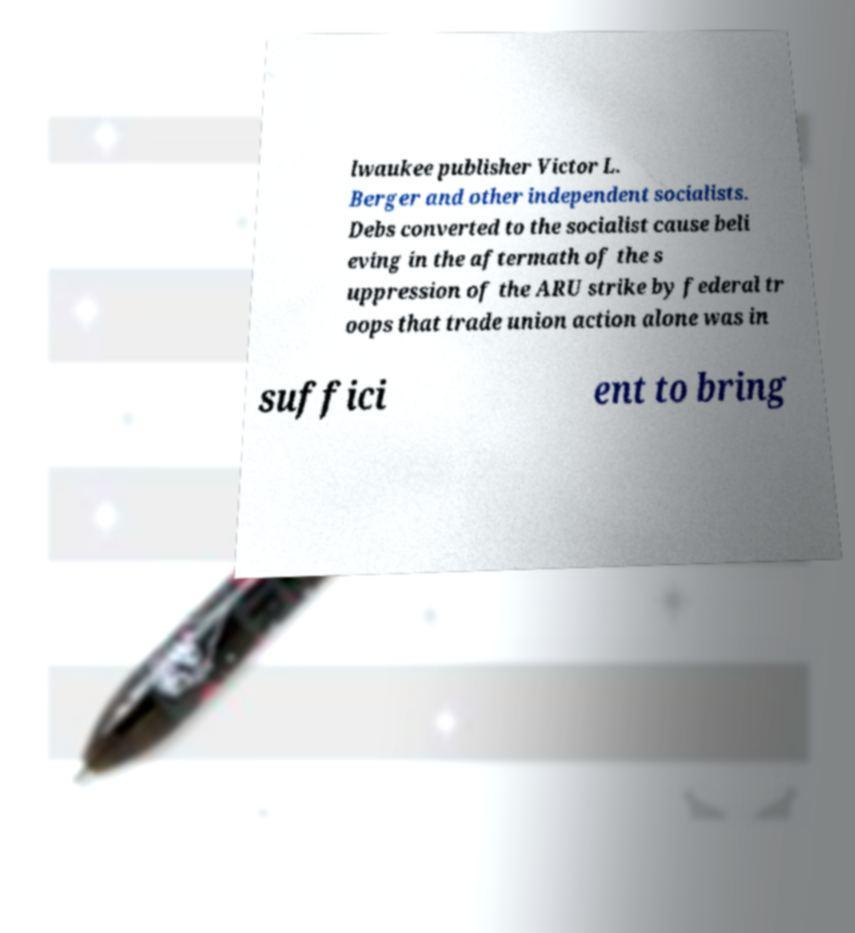Can you accurately transcribe the text from the provided image for me? lwaukee publisher Victor L. Berger and other independent socialists. Debs converted to the socialist cause beli eving in the aftermath of the s uppression of the ARU strike by federal tr oops that trade union action alone was in suffici ent to bring 